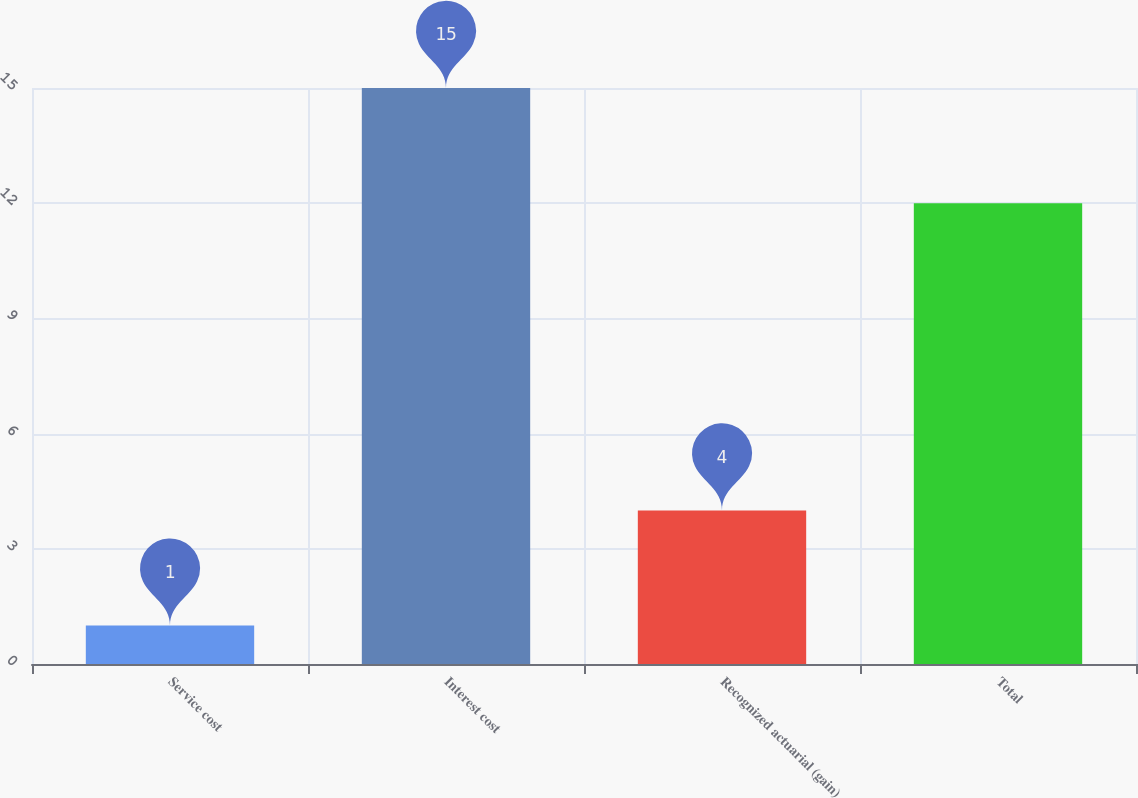Convert chart. <chart><loc_0><loc_0><loc_500><loc_500><bar_chart><fcel>Service cost<fcel>Interest cost<fcel>Recognized actuarial (gain)<fcel>Total<nl><fcel>1<fcel>15<fcel>4<fcel>12<nl></chart> 